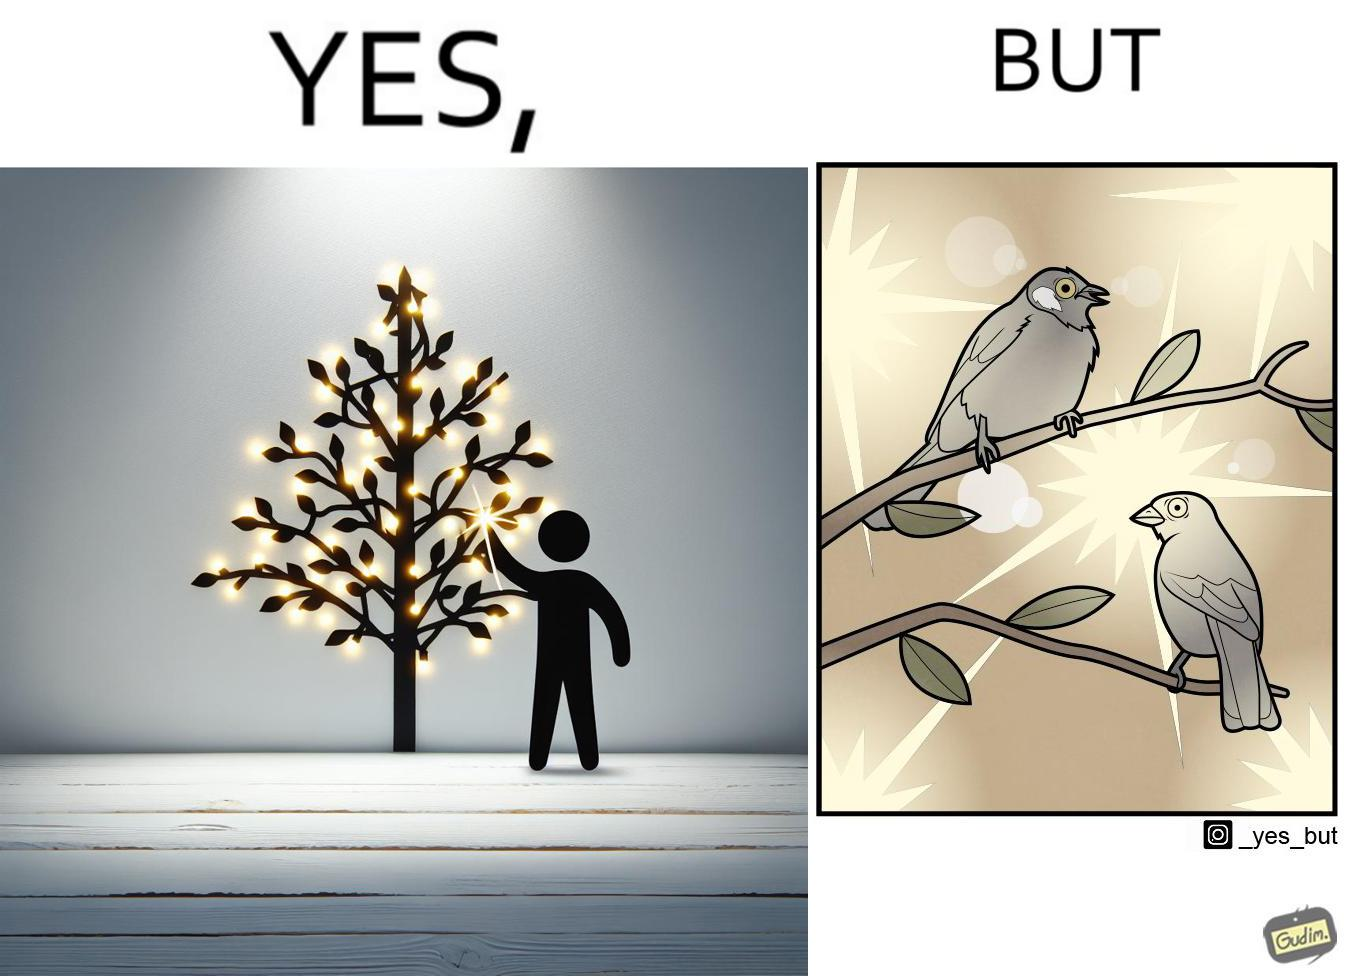What does this image depict? The images are ironic since they show how putting a lot of lights as decorations on trees make them beautiful to look at for us but cause trouble to the birds who actually live on trees for no good reason 